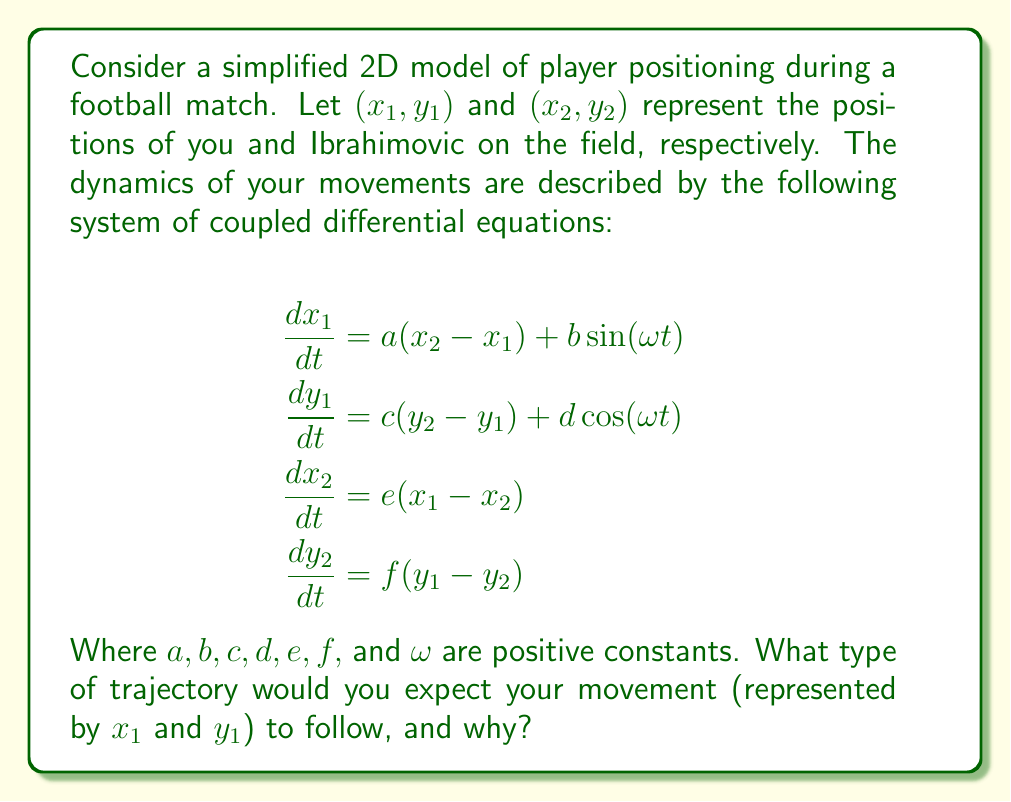What is the answer to this math problem? To analyze the trajectory of your movement, let's break down the system of equations:

1. Your motion is influenced by two factors:
   a) The difference between your position and Ibrahimovic's position ($(x_2 - x_1)$ and $(y_2 - y_1)$)
   b) A periodic forcing term ($b\sin(\omega t)$ and $d\cos(\omega t)$)

2. Ibrahimovic's motion is solely based on the difference between your positions.

3. The coupling terms (with coefficients $a$ and $c$) represent your tendency to move towards Ibrahimovic's position.

4. The periodic forcing terms represent external factors like the movement of the ball or other players.

5. This system combines elements of:
   - A coupled oscillator (due to the interaction between players)
   - A forced oscillator (due to the sinusoidal terms)

6. In the absence of the forcing terms, the system would tend towards an equilibrium where both players converge to the same position.

7. However, the presence of the periodic forcing terms introduces a continuous perturbation to this equilibrium.

8. The combination of the coupling and forcing terms is likely to result in a quasi-periodic motion.

9. Your trajectory would follow a path that is influenced by both your interaction with Ibrahimovic and the external periodic forcing.

10. This would likely result in a complex, looping pattern that never exactly repeats but maintains a general structure.

Therefore, your movement would be expected to follow a quasi-periodic trajectory, combining elements of periodic motion (from the forcing terms) with the dynamic interaction between you and Ibrahimovic.
Answer: Quasi-periodic trajectory 